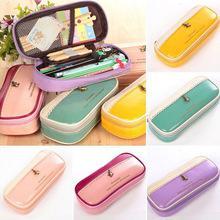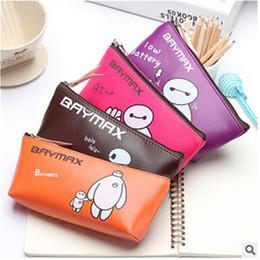The first image is the image on the left, the second image is the image on the right. Assess this claim about the two images: "The bags in one of the images are decorated with words.". Correct or not? Answer yes or no. Yes. The first image is the image on the left, the second image is the image on the right. Assess this claim about the two images: "Left image shows an open blue case filled with writing supplies.". Correct or not? Answer yes or no. No. 